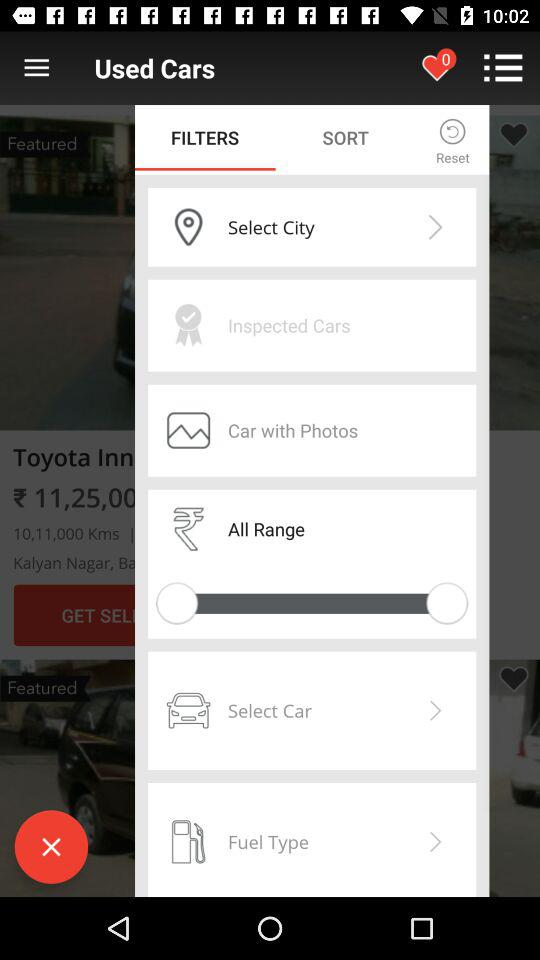Which tab has been selected? The tab "FILTERS" has been selected. 